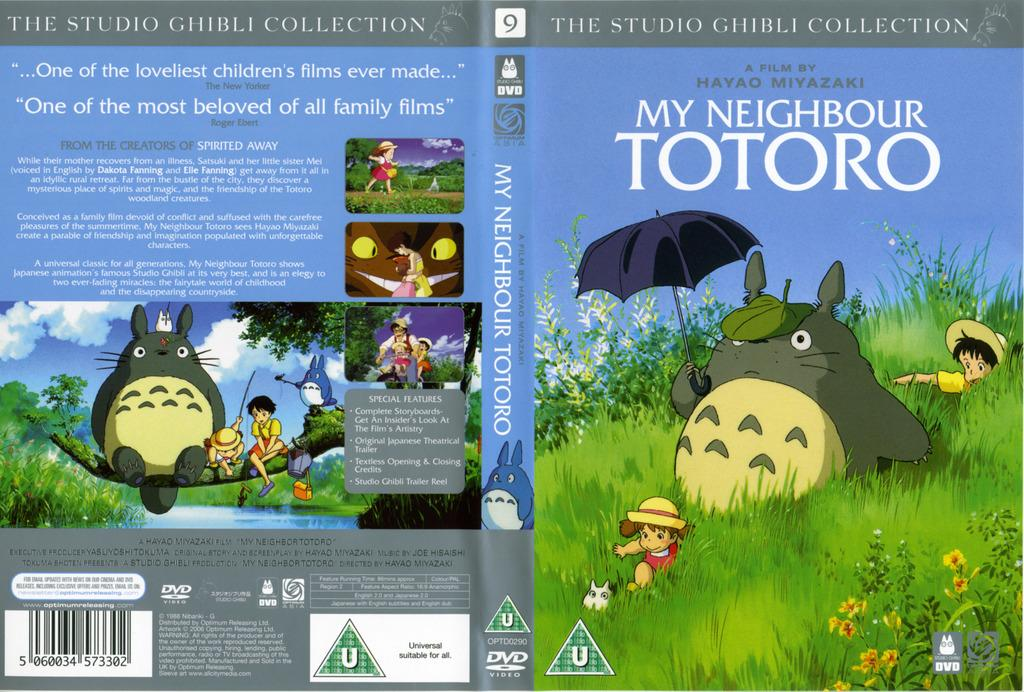What type of image is displayed in the center of the image? There is a cover photo in the image. What is depicted in the cover photo? The cover photo contains cartoons. What type of berry is used to flavor the stew in the image? There is no stew or berry present in the image; it only contains a cover photo with cartoons. 